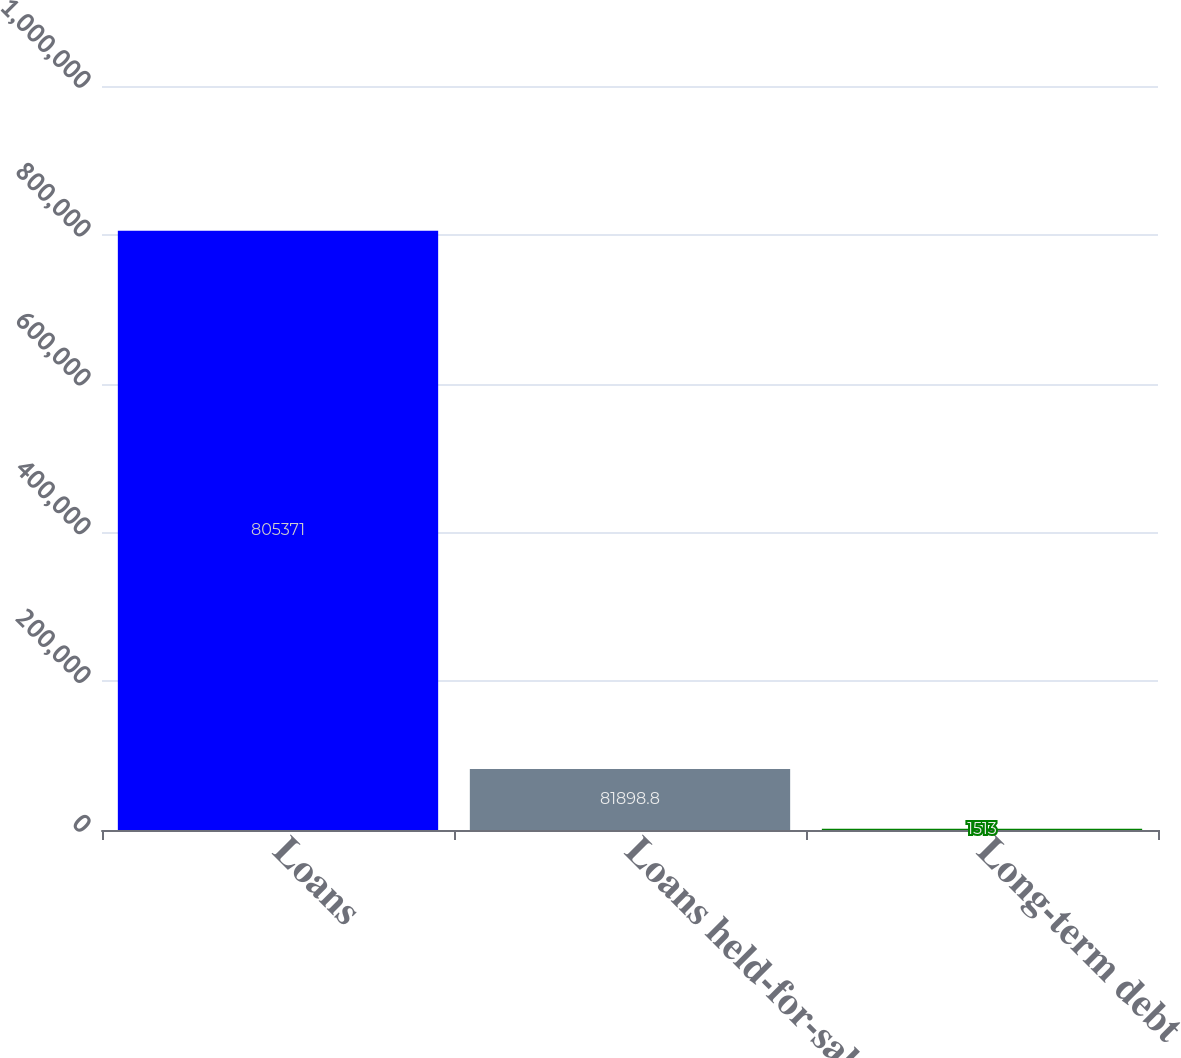<chart> <loc_0><loc_0><loc_500><loc_500><bar_chart><fcel>Loans<fcel>Loans held-for-sale<fcel>Long-term debt<nl><fcel>805371<fcel>81898.8<fcel>1513<nl></chart> 